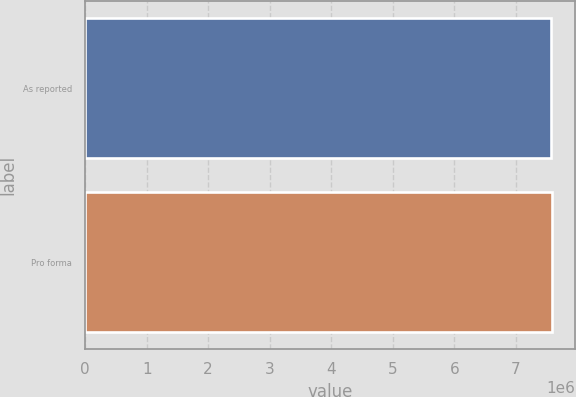Convert chart. <chart><loc_0><loc_0><loc_500><loc_500><bar_chart><fcel>As reported<fcel>Pro forma<nl><fcel>7.56889e+06<fcel>7.58666e+06<nl></chart> 